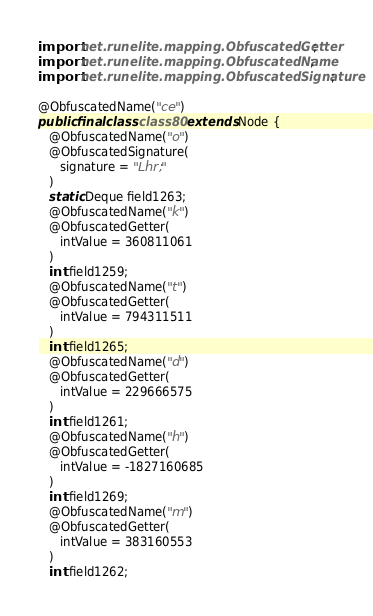<code> <loc_0><loc_0><loc_500><loc_500><_Java_>import net.runelite.mapping.ObfuscatedGetter;
import net.runelite.mapping.ObfuscatedName;
import net.runelite.mapping.ObfuscatedSignature;

@ObfuscatedName("ce")
public final class class80 extends Node {
   @ObfuscatedName("o")
   @ObfuscatedSignature(
      signature = "Lhr;"
   )
   static Deque field1263;
   @ObfuscatedName("k")
   @ObfuscatedGetter(
      intValue = 360811061
   )
   int field1259;
   @ObfuscatedName("t")
   @ObfuscatedGetter(
      intValue = 794311511
   )
   int field1265;
   @ObfuscatedName("d")
   @ObfuscatedGetter(
      intValue = 229666575
   )
   int field1261;
   @ObfuscatedName("h")
   @ObfuscatedGetter(
      intValue = -1827160685
   )
   int field1269;
   @ObfuscatedName("m")
   @ObfuscatedGetter(
      intValue = 383160553
   )
   int field1262;</code> 